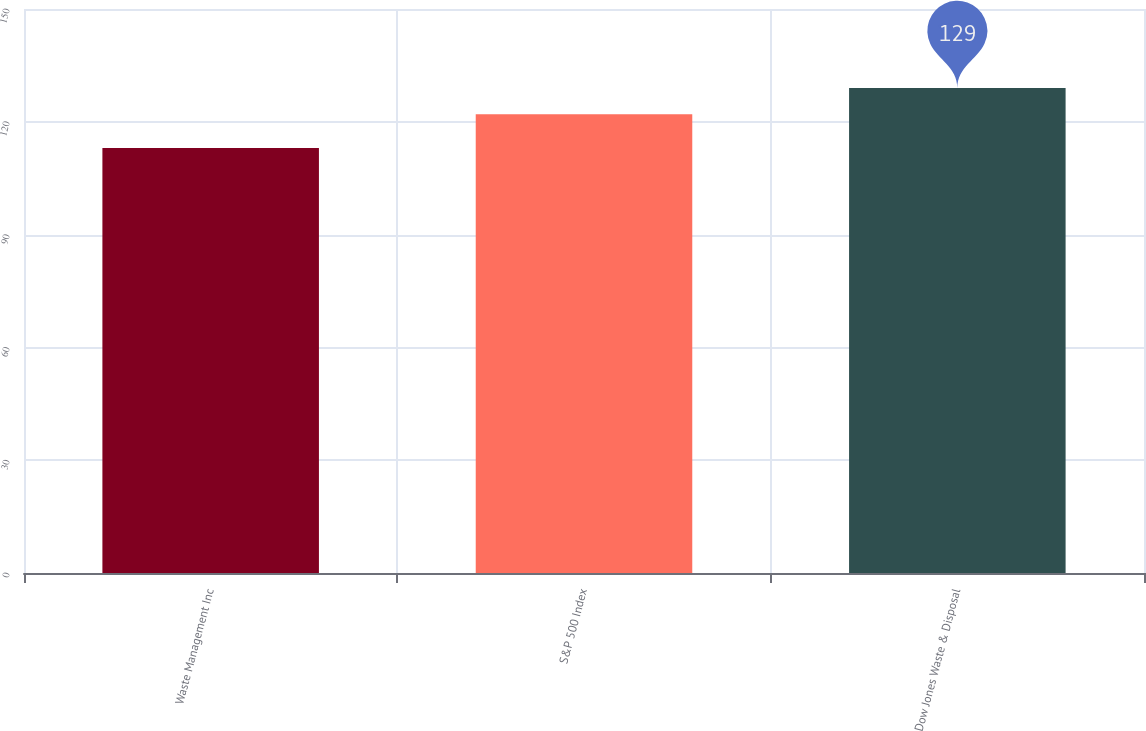Convert chart to OTSL. <chart><loc_0><loc_0><loc_500><loc_500><bar_chart><fcel>Waste Management Inc<fcel>S&P 500 Index<fcel>Dow Jones Waste & Disposal<nl><fcel>113<fcel>122<fcel>129<nl></chart> 